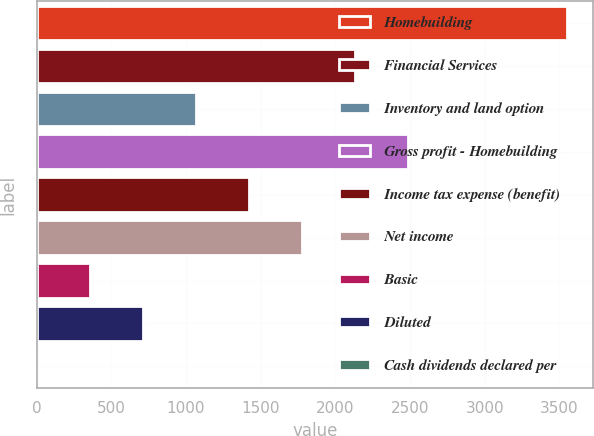<chart> <loc_0><loc_0><loc_500><loc_500><bar_chart><fcel>Homebuilding<fcel>Financial Services<fcel>Inventory and land option<fcel>Gross profit - Homebuilding<fcel>Income tax expense (benefit)<fcel>Net income<fcel>Basic<fcel>Diluted<fcel>Cash dividends declared per<nl><fcel>3549.6<fcel>2129.8<fcel>1064.97<fcel>2484.75<fcel>1419.91<fcel>1774.86<fcel>355.09<fcel>710.03<fcel>0.15<nl></chart> 